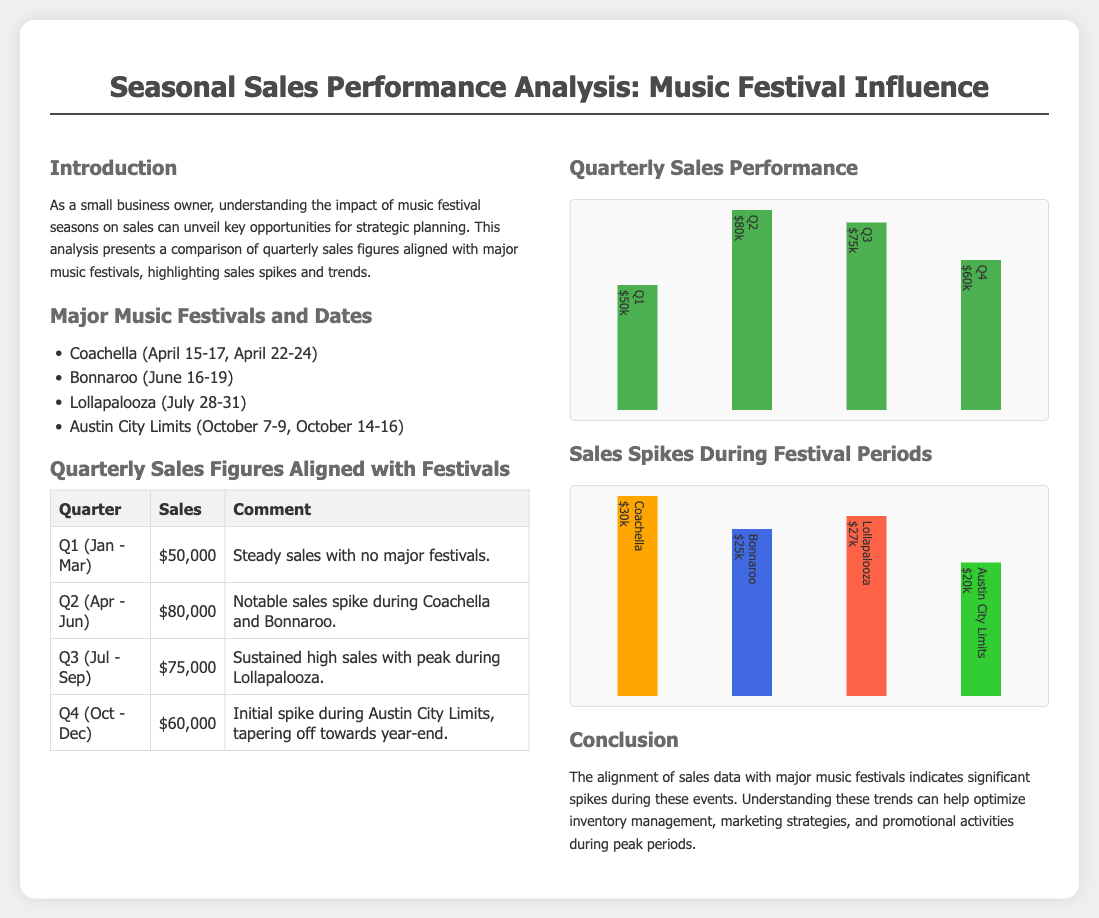What were the total sales in Q2? The sales figures for Q2 (April - June) are provided in the table, which shows $80,000.
Answer: $80,000 Which festival occurs in October? The document lists Austin City Limits as a major music festival occurring in October.
Answer: Austin City Limits What percentage of sales did Lollapalooza generate? The sales data shows that Lollapalooza generated $27,000, which corresponds to its height representation in the "Sales Spikes" chart.
Answer: $27,000 What was the sales spike during Coachella? The document indicates that the sales spike during Coachella was $30,000, detailed in the related chart.
Answer: $30,000 How many major music festivals are listed? The document includes a list of four major music festivals within the section describing them.
Answer: Four 